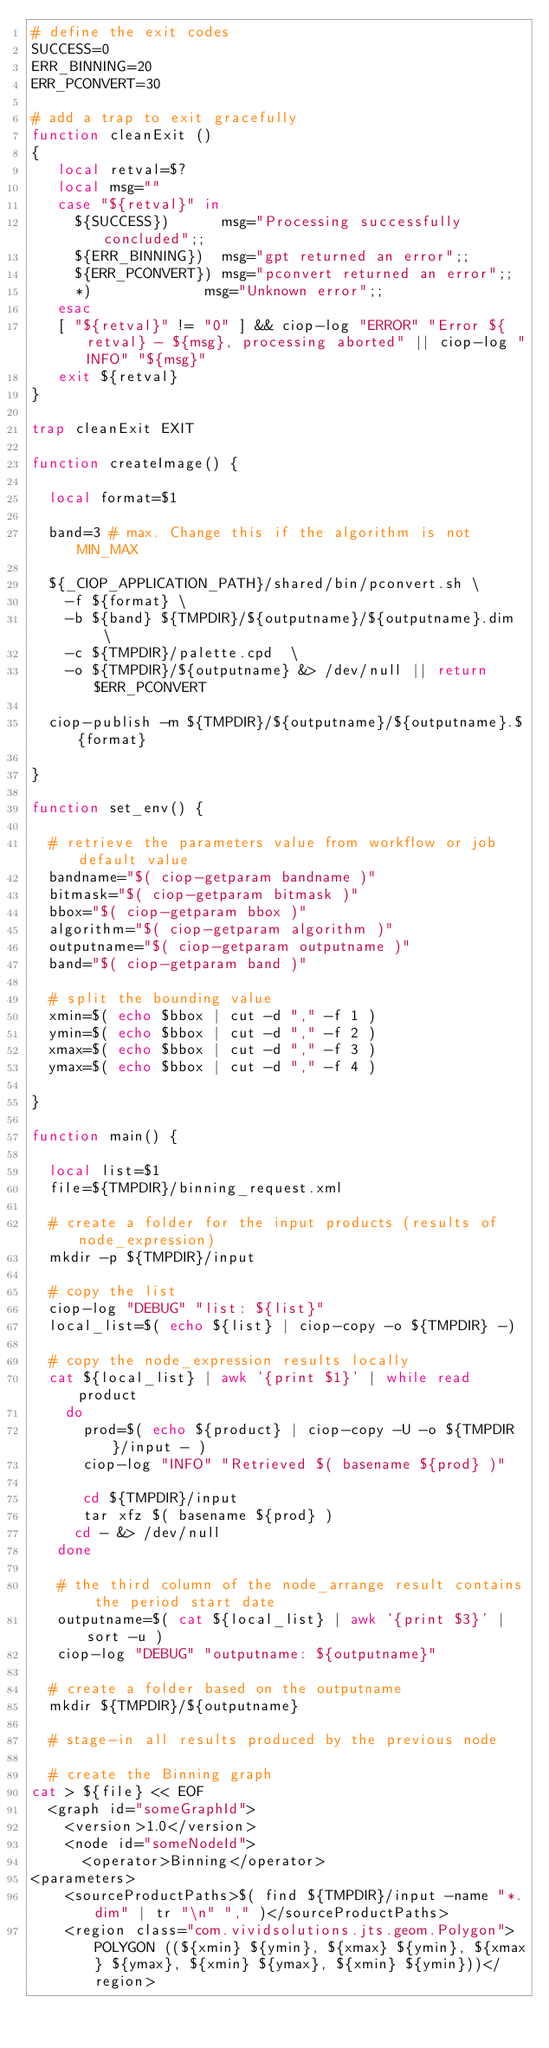Convert code to text. <code><loc_0><loc_0><loc_500><loc_500><_Bash_># define the exit codes
SUCCESS=0
ERR_BINNING=20
ERR_PCONVERT=30

# add a trap to exit gracefully
function cleanExit ()
{
   local retval=$?
   local msg=""
   case "${retval}" in
     ${SUCCESS})      msg="Processing successfully concluded";;
     ${ERR_BINNING})  msg="gpt returned an error";;
     ${ERR_PCONVERT}) msg="pconvert returned an error";;
     *)             msg="Unknown error";;
   esac
   [ "${retval}" != "0" ] && ciop-log "ERROR" "Error ${retval} - ${msg}, processing aborted" || ciop-log "INFO" "${msg}"
   exit ${retval}
}

trap cleanExit EXIT

function createImage() {

  local format=$1

  band=3 # max. Change this if the algorithm is not MIN_MAX

  ${_CIOP_APPLICATION_PATH}/shared/bin/pconvert.sh \
    -f ${format} \
    -b ${band} ${TMPDIR}/${outputname}/${outputname}.dim  \
    -c ${TMPDIR}/palette.cpd  \
    -o ${TMPDIR}/${outputname} &> /dev/null || return $ERR_PCONVERT

  ciop-publish -m ${TMPDIR}/${outputname}/${outputname}.${format}

}

function set_env() {

  # retrieve the parameters value from workflow or job default value
  bandname="$( ciop-getparam bandname )"
  bitmask="$( ciop-getparam bitmask )"
  bbox="$( ciop-getparam bbox )"
  algorithm="$( ciop-getparam algorithm )"
  outputname="$( ciop-getparam outputname )"
  band="$( ciop-getparam band )"

  # split the bounding value
  xmin=$( echo $bbox | cut -d "," -f 1 )
  ymin=$( echo $bbox | cut -d "," -f 2 )
  xmax=$( echo $bbox | cut -d "," -f 3 )
  ymax=$( echo $bbox | cut -d "," -f 4 )

}

function main() {

  local list=$1
  file=${TMPDIR}/binning_request.xml

  # create a folder for the input products (results of node_expression)
  mkdir -p ${TMPDIR}/input

  # copy the list
  ciop-log "DEBUG" "list: ${list}"
  local_list=$( echo ${list} | ciop-copy -o ${TMPDIR} -)

  # copy the node_expression results locally
  cat ${local_list} | awk '{print $1}' | while read product
    do
      prod=$( echo ${product} | ciop-copy -U -o ${TMPDIR}/input - )
      ciop-log "INFO" "Retrieved $( basename ${prod} )"

      cd ${TMPDIR}/input
      tar xfz $( basename ${prod} )
     cd - &> /dev/null
   done

   # the third column of the node_arrange result contains the period start date
   outputname=$( cat ${local_list} | awk '{print $3}' | sort -u )
   ciop-log "DEBUG" "outputname: ${outputname}"

  # create a folder based on the outputname
  mkdir ${TMPDIR}/${outputname}

  # stage-in all results produced by the previous node

  # create the Binning graph
cat > ${file} << EOF
  <graph id="someGraphId">
    <version>1.0</version>
    <node id="someNodeId">
      <operator>Binning</operator>
<parameters>
    <sourceProductPaths>$( find ${TMPDIR}/input -name "*.dim" | tr "\n" "," )</sourceProductPaths>
    <region class="com.vividsolutions.jts.geom.Polygon">POLYGON ((${xmin} ${ymin}, ${xmax} ${ymin}, ${xmax} ${ymax}, ${xmin} ${ymax}, ${xmin} ${ymin}))</region></code> 